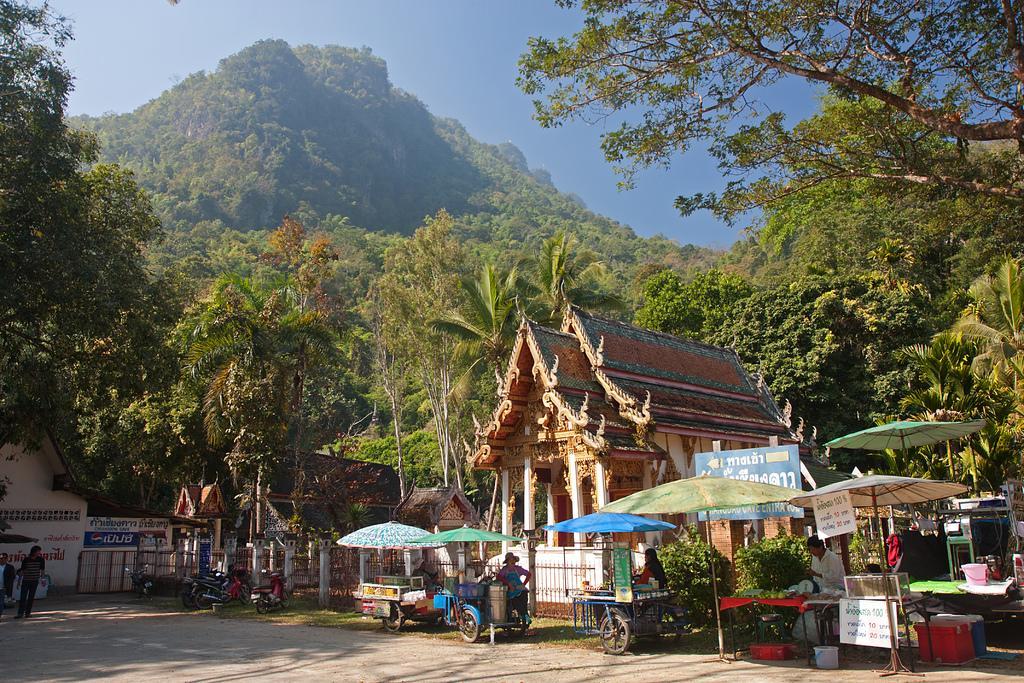How would you summarize this image in a sentence or two? This picture is taken from the outside of the city. In this image, on the left side, we can see two men are walking. On the left side, we can also see some trees. On the right side, we can see some umbrella and a few people are standing under the umbrella in front of a vehicle, trees. On the right side, we can also see a building, pillars. In the background, we can also see a building, wall and a board with some text, trees. At the top, we can see a sky, at the bottom, we can see a road. 